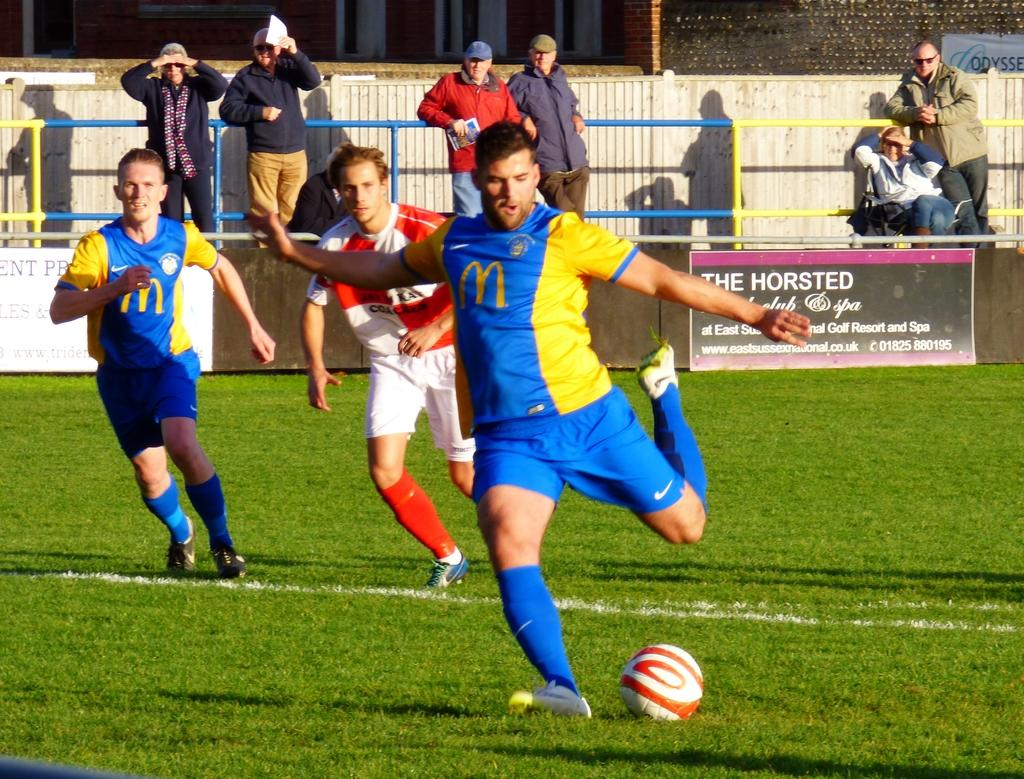What are the three men in the image doing? The three men in the image are running. What is on the floor in the image? There is a ball on the floor in the image. Are there any spectators in the image? Yes, there are people standing behind the men, watching them. What type of cake is being served to the men running in the image? There is no cake present in the image; the men are running and there is a ball on the floor. 